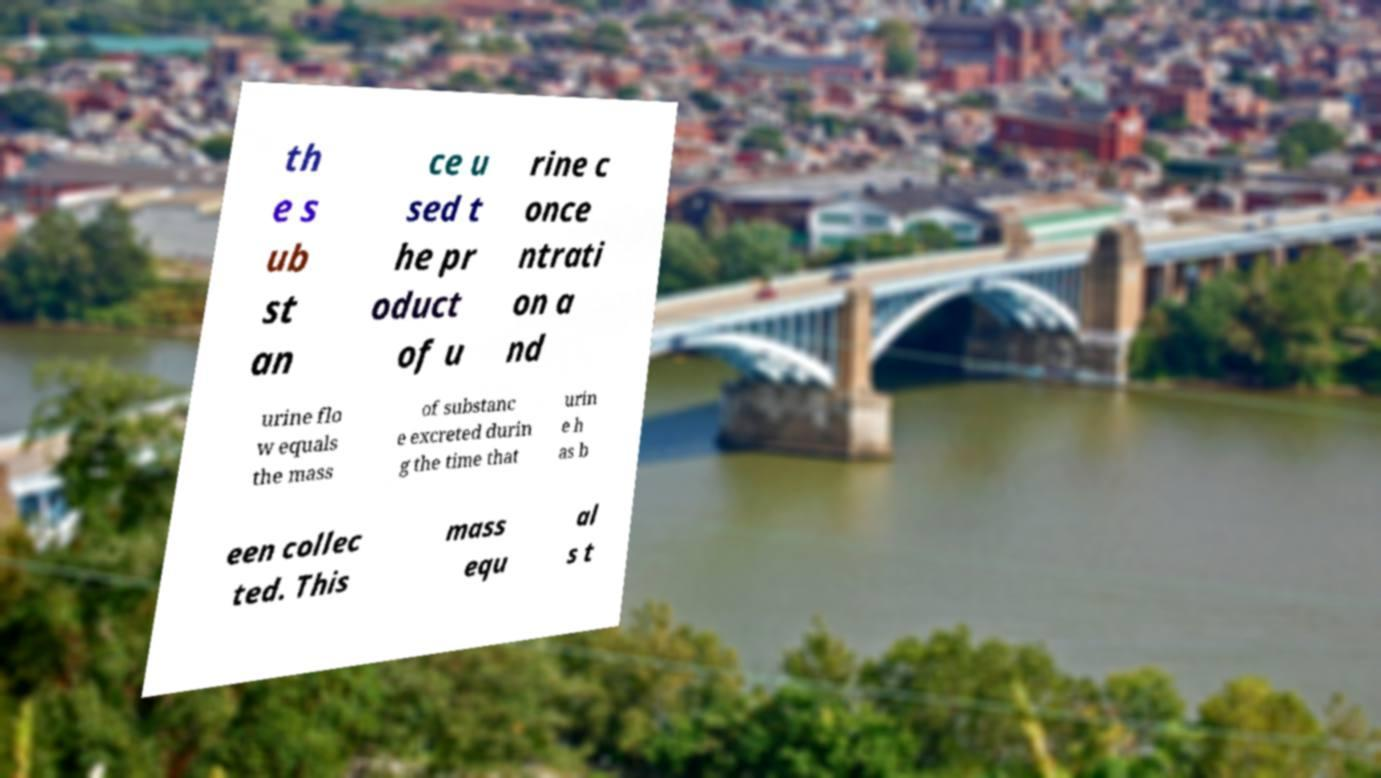There's text embedded in this image that I need extracted. Can you transcribe it verbatim? th e s ub st an ce u sed t he pr oduct of u rine c once ntrati on a nd urine flo w equals the mass of substanc e excreted durin g the time that urin e h as b een collec ted. This mass equ al s t 